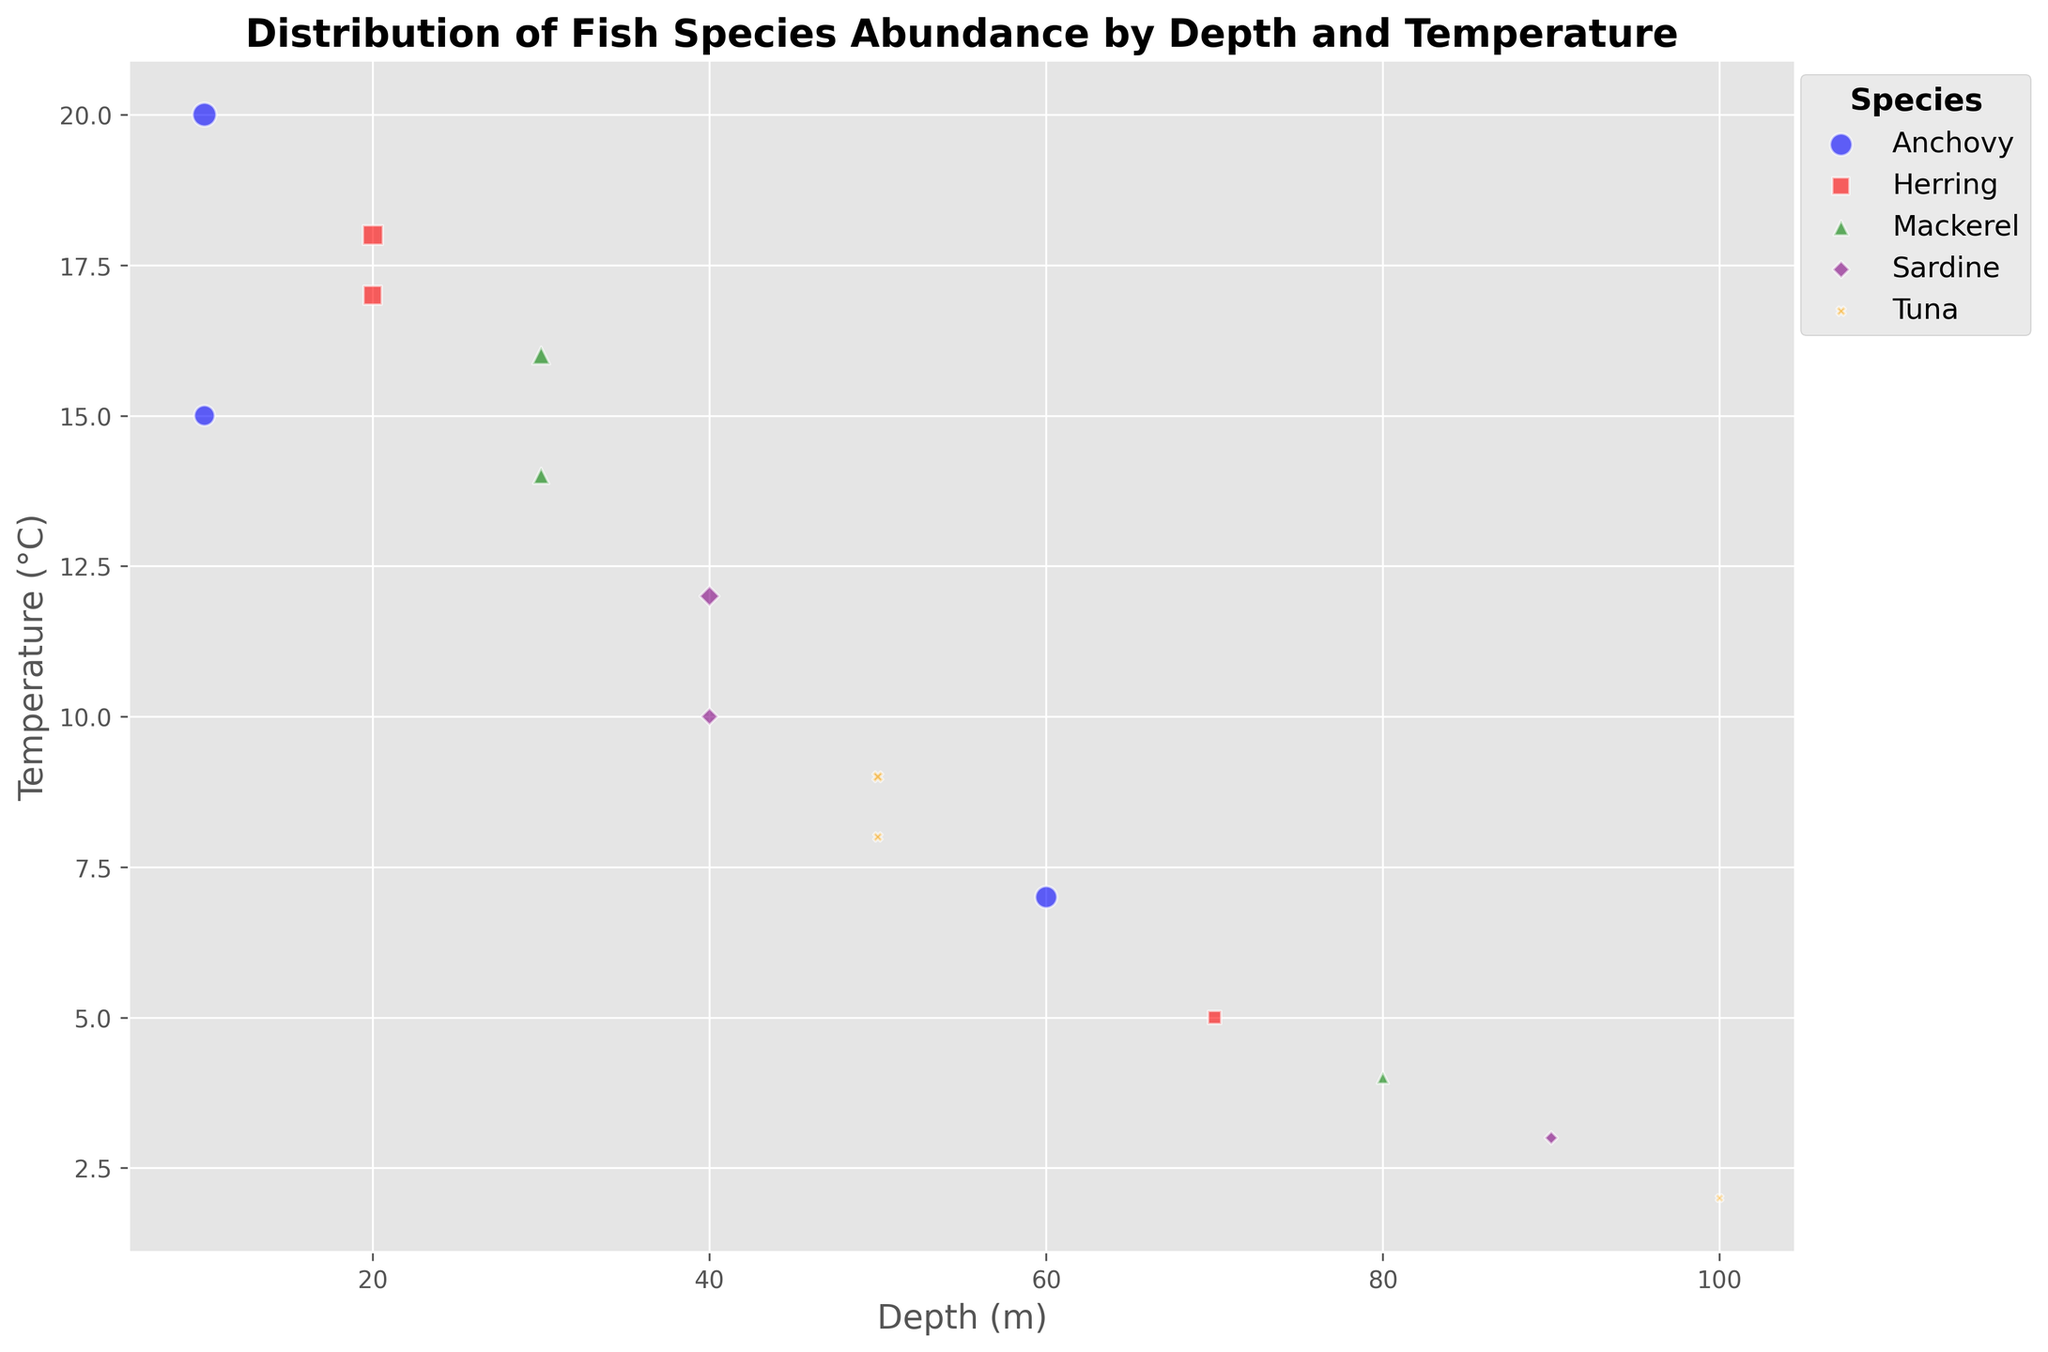How does the abundance of Anchovy change with increasing depth? To understand the change in abundance of Anchovy with increasing depth, compare the size of the bubbles corresponding to Anchovy at different depths. Starting at 10 meters depth, the abundance is 150. At 20 meters, it increases to 200. However, at 60 meters, the abundance decreases to 170.
Answer: It increases and then decreases Which species is found at the lowest temperature? Look for the species associated with the bubble at the lowest point on the y-axis, representing the lowest temperature. The bubble at 2°C has the label Tuna.
Answer: Tuna At which depth do Herring have the highest abundance? Find the Herring bubbles and look at their relative sizes to determine which one is the largest. The largest Herring bubble is found at a depth of 20 meters.
Answer: 20 meters Compare the abundance of Mackerel at 40 and 80 meters. Which depth has higher abundance? Check the sizes of the Mackerel bubbles at 40 and 80 meters depths. The bubble at 40 meters is larger than the one at 80 meters.
Answer: 40 meters Which species has the largest overall bubble size, indicating the highest abundance, in any depth or temperature range? Compare all the bubble sizes visually across different species. The Anchovy bubble at 10 meters depth and 20°C is the largest, indicating it has the highest abundance.
Answer: Anchovy How many species are plotted in the figure? Identify unique species labels present in the legend or within the bubbles. The legend shows five different species: Anchovy, Herring, Mackerel, Sardine, and Tuna.
Answer: 5 Is there a trend in the temperature when the depth increases? Observe the overall trend of the bubble positions along the y-axis as the depth (x-axis) increases. There is a downward trend in temperature with increasing depth.
Answer: Decrease Compare the abundance of species found at 10 meters depth. Which has the highest abundance? Locate all the bubbles at 10 meters depth and compare their sizes. The Anchovy bubble is the largest at this depth.
Answer: Anchovy What is the temperature at which the highest abundance of Sardine is observed? Identify the largest Sardine bubble and note its y-axis position. The largest Sardine bubble is at 40 meters depth and 10°C.
Answer: 10°C Among the species plotted, which has both the highest and lowest temperatures? Identify the species with bubbles at both the highest and lowest positions on the y-axis (20°C and 2°C respectively). Anchovy has the highest temperature bubble (20°C) and Tuna has the lowest temperature bubble (2°C).
Answer: Anchovy (highest) and Tuna (lowest) 